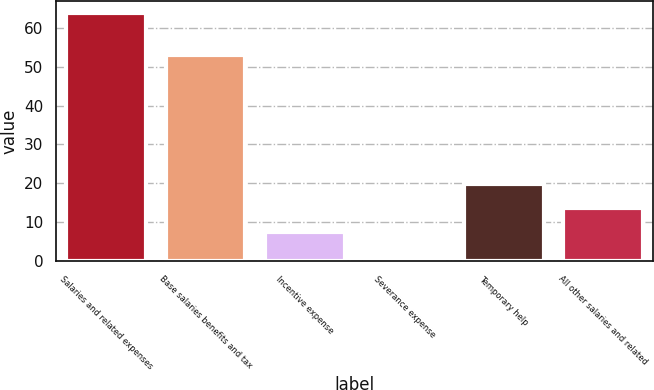Convert chart. <chart><loc_0><loc_0><loc_500><loc_500><bar_chart><fcel>Salaries and related expenses<fcel>Base salaries benefits and tax<fcel>Incentive expense<fcel>Severance expense<fcel>Temporary help<fcel>All other salaries and related<nl><fcel>63.8<fcel>52.9<fcel>7.37<fcel>1.1<fcel>19.91<fcel>13.64<nl></chart> 